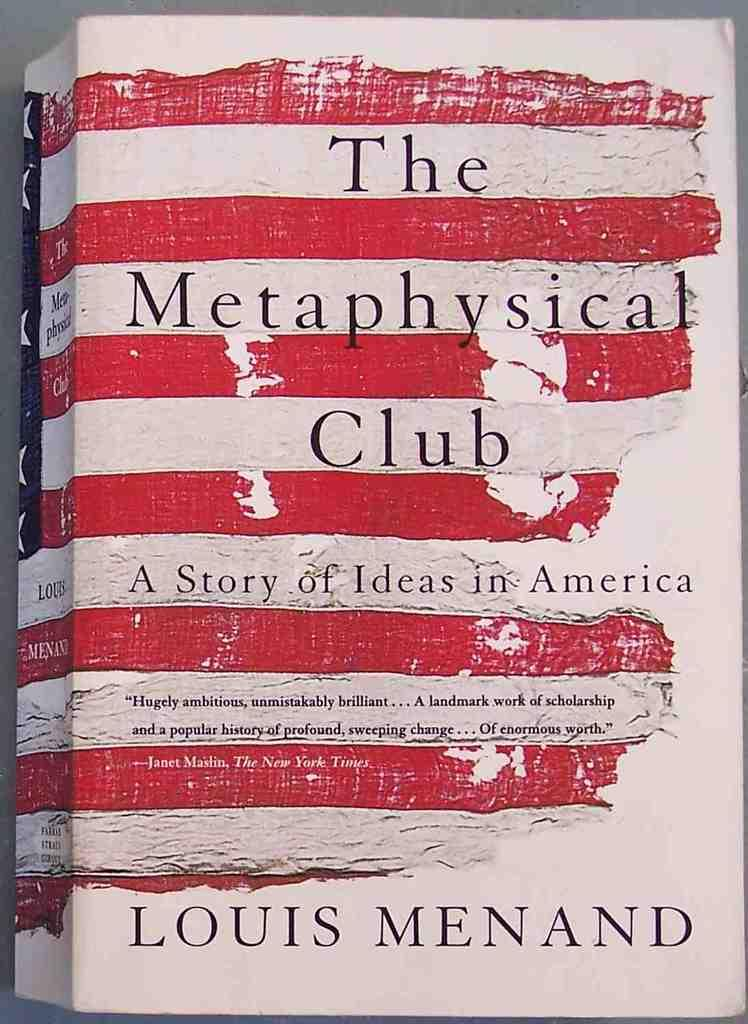<image>
Create a compact narrative representing the image presented. The book is titled The Metaphysical Club A Story of Ideas in America, 